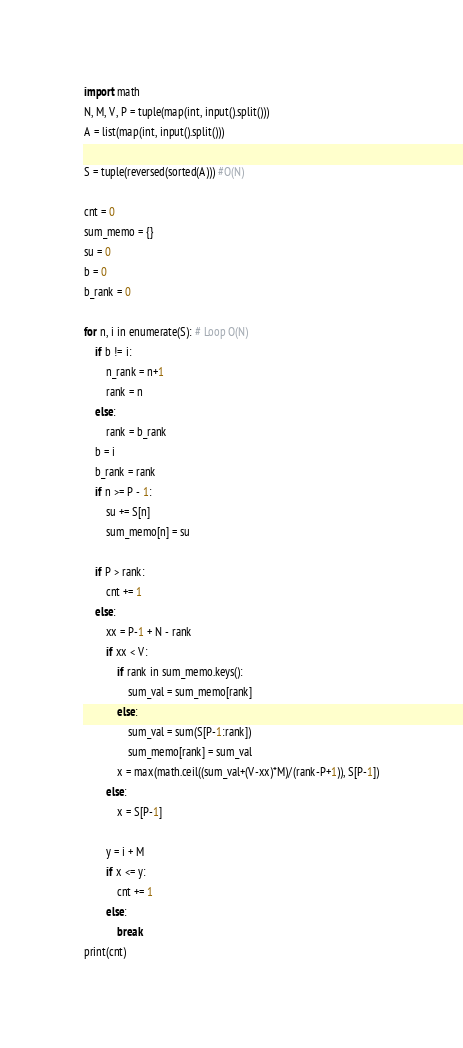Convert code to text. <code><loc_0><loc_0><loc_500><loc_500><_Python_>import math
N, M, V, P = tuple(map(int, input().split()))
A = list(map(int, input().split()))

S = tuple(reversed(sorted(A))) #O(N)

cnt = 0
sum_memo = {}
su = 0
b = 0
b_rank = 0

for n, i in enumerate(S): # Loop O(N)
    if b != i:
        n_rank = n+1
        rank = n
    else: 
        rank = b_rank
    b = i
    b_rank = rank
    if n >= P - 1:
        su += S[n]
        sum_memo[n] = su
    
    if P > rank:
        cnt += 1
    else:
        xx = P-1 + N - rank
        if xx < V:
            if rank in sum_memo.keys():
                sum_val = sum_memo[rank]
            else:
                sum_val = sum(S[P-1:rank])
                sum_memo[rank] = sum_val
            x = max(math.ceil((sum_val+(V-xx)*M)/(rank-P+1)), S[P-1])
        else:
            x = S[P-1]
                    
        y = i + M
        if x <= y:
            cnt += 1
        else:
            break
print(cnt)
</code> 